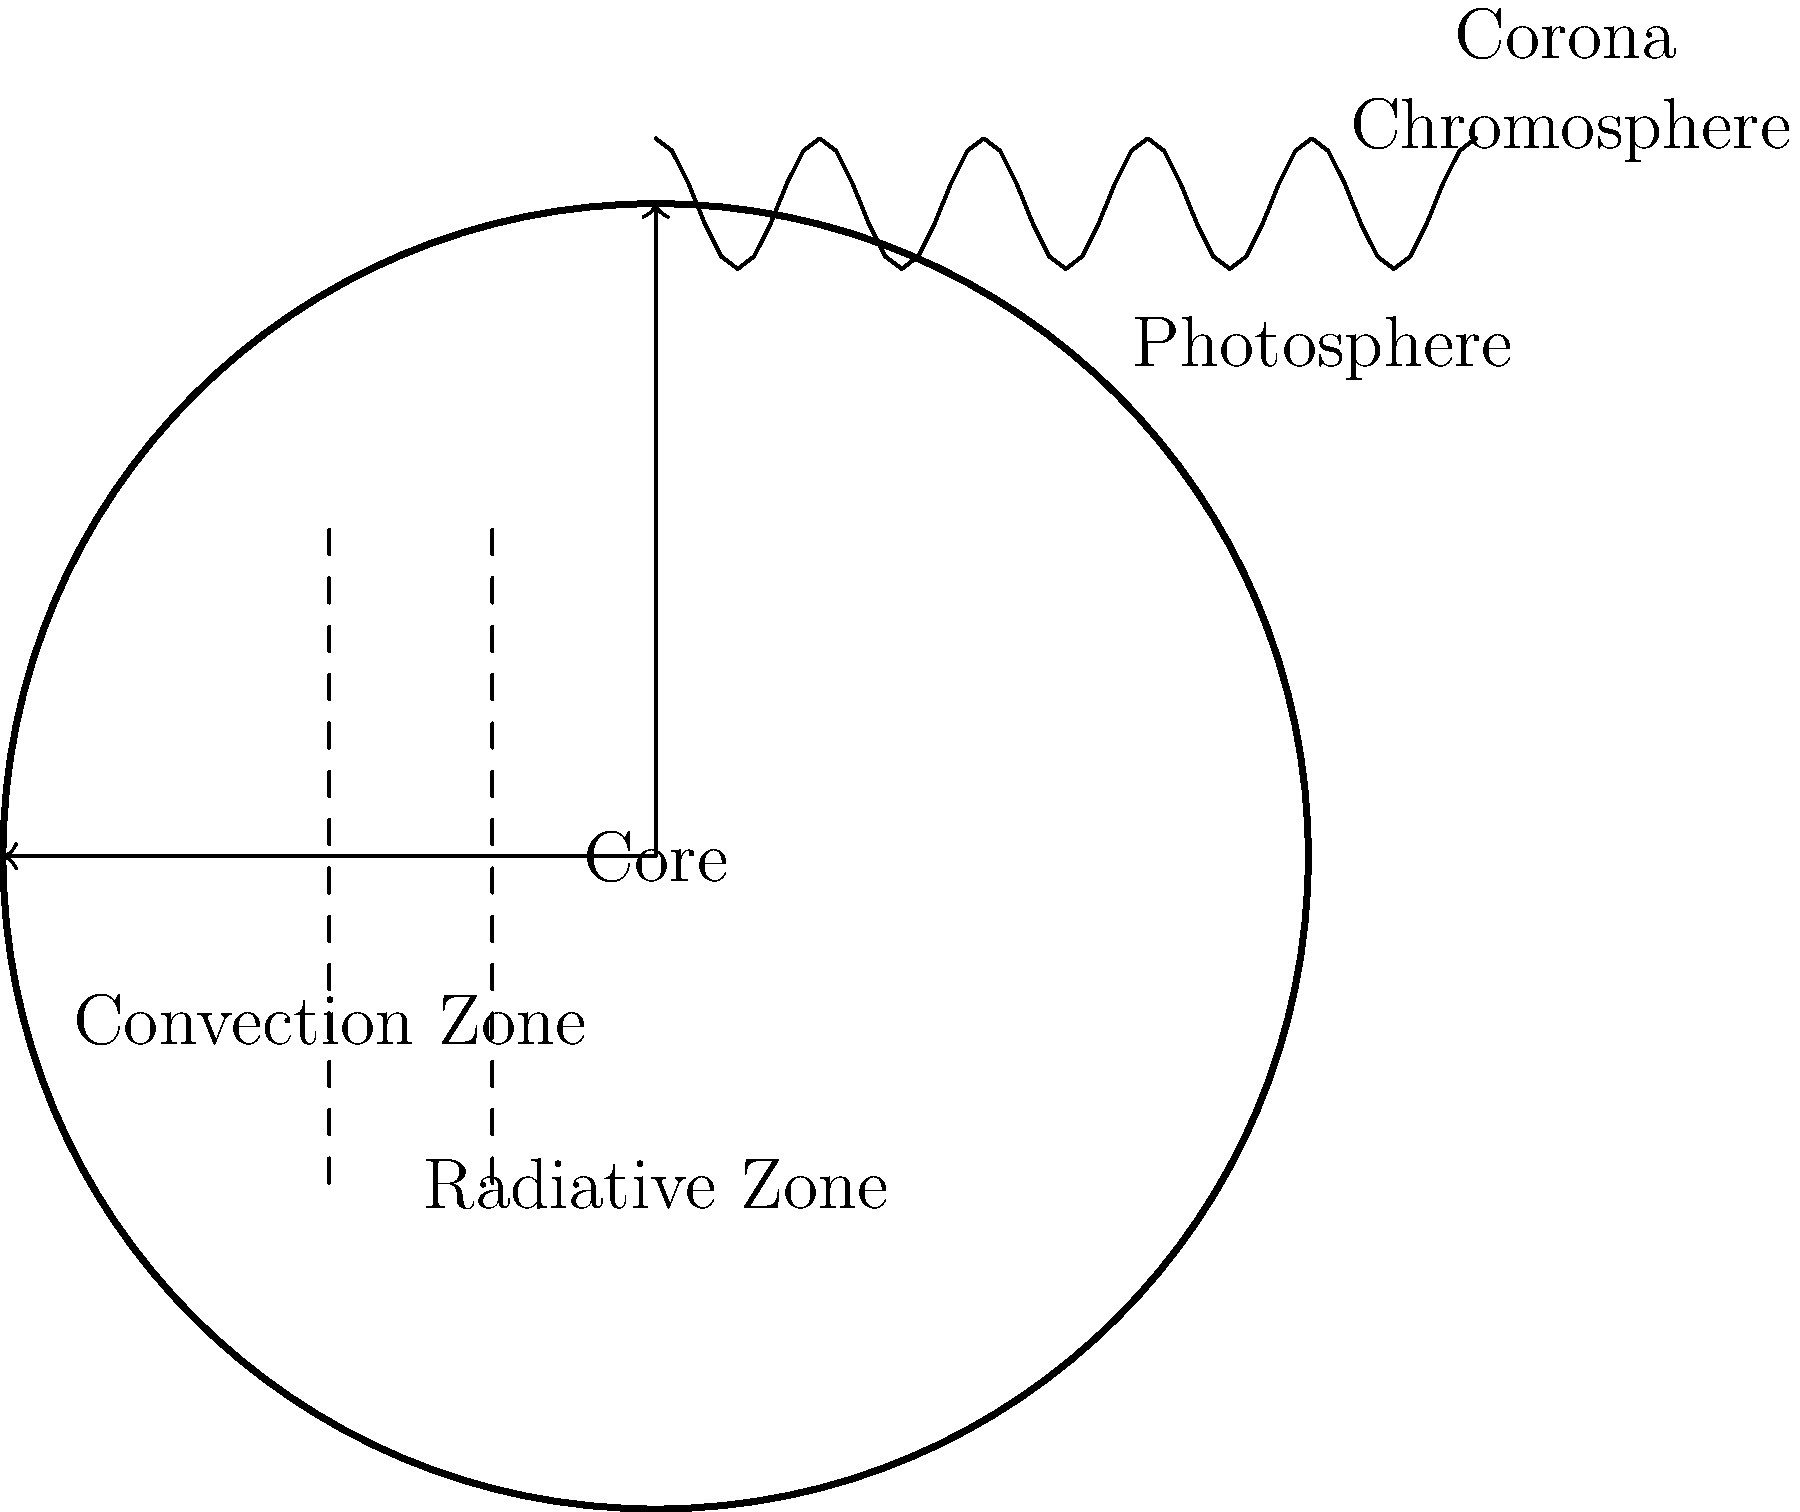As an expert in neuroimaging, you're familiar with analyzing complex structural data. Apply this knowledge to astronomy: In the provided cross-sectional diagram of the Sun, which layer is responsible for the visible light we observe, and how does its position relate to the energy transfer mechanisms within the Sun? To answer this question, let's break down the structure of the Sun and the energy transfer mechanisms:

1. Core: This is the central region where nuclear fusion occurs, generating the Sun's energy.

2. Radiative Zone: Surrounding the core, energy is transferred outward through radiation.

3. Convection Zone: Above the radiative zone, energy is transferred through convection currents.

4. Photosphere: This is the visible surface of the Sun, where the light we observe originates.

5. Chromosphere: A thin layer above the photosphere, visible during solar eclipses.

6. Corona: The outermost layer of the Sun's atmosphere.

The photosphere is responsible for the visible light we observe from Earth. Its position is crucial in understanding the energy transfer within the Sun:

1. It sits above the convection zone, where energy is transferred through the movement of hot plasma.
2. The photosphere marks the transition from opaque to transparent solar material.
3. At this layer, the temperature is cool enough (about 5800K) for atoms to retain some of their electrons, allowing for the emission of visible light.

The photosphere's location at the boundary between the convection zone and the solar atmosphere is significant because:

1. It represents the point where energy transfer shifts from convection to radiation.
2. The granular pattern observed on the photosphere is a direct result of the convection currents below.
3. It acts as a "window" through which we can indirectly observe the internal processes of the Sun.

Understanding the photosphere's role is similar to analyzing brain imaging data, where we observe surface activity to infer deeper structural processes.
Answer: Photosphere; located at the convection-to-radiation transition boundary 